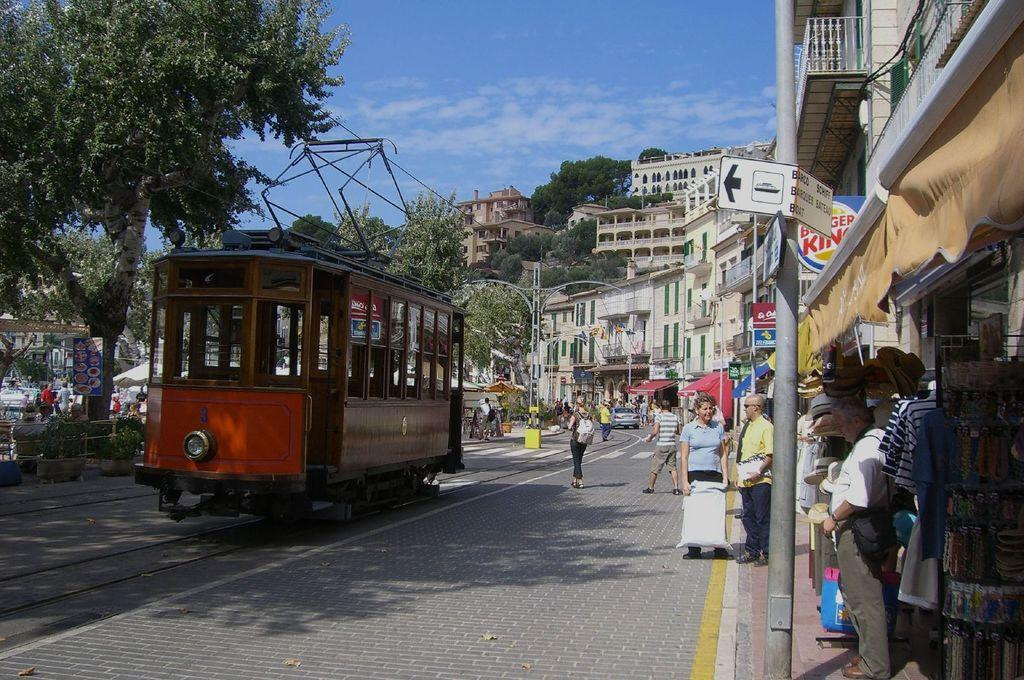Provide a one-sentence caption for the provided image. a red trolley in on the street in front of Burger King. 